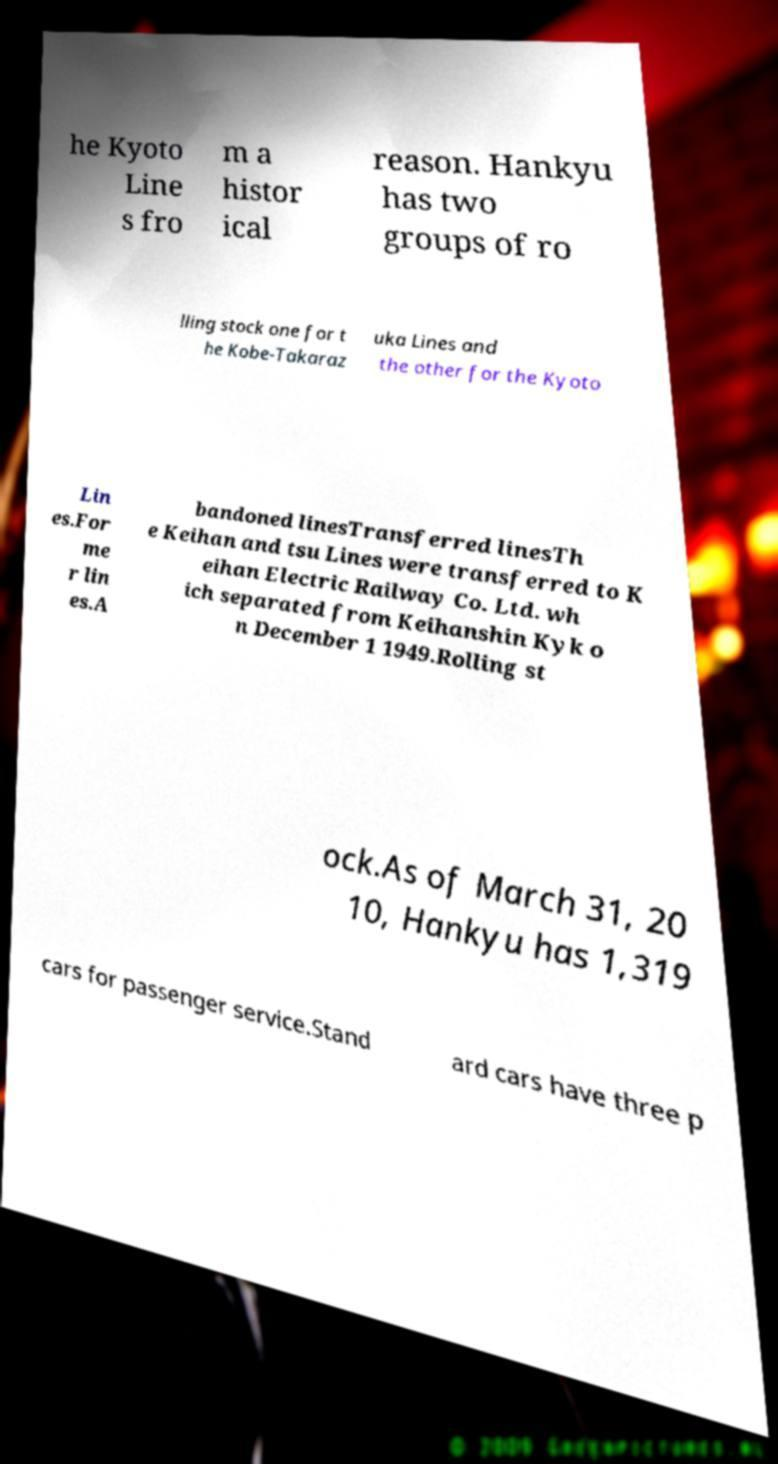Could you extract and type out the text from this image? he Kyoto Line s fro m a histor ical reason. Hankyu has two groups of ro lling stock one for t he Kobe-Takaraz uka Lines and the other for the Kyoto Lin es.For me r lin es.A bandoned linesTransferred linesTh e Keihan and tsu Lines were transferred to K eihan Electric Railway Co. Ltd. wh ich separated from Keihanshin Kyk o n December 1 1949.Rolling st ock.As of March 31, 20 10, Hankyu has 1,319 cars for passenger service.Stand ard cars have three p 